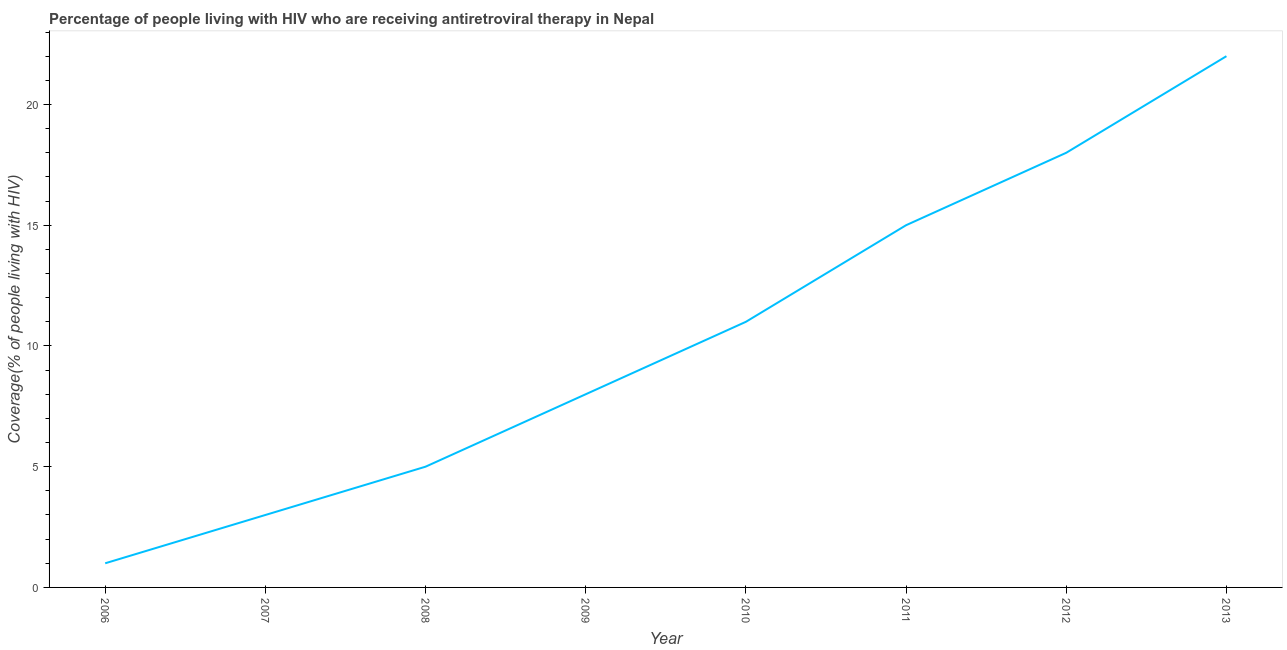What is the antiretroviral therapy coverage in 2012?
Keep it short and to the point. 18. Across all years, what is the maximum antiretroviral therapy coverage?
Provide a short and direct response. 22. Across all years, what is the minimum antiretroviral therapy coverage?
Your answer should be very brief. 1. In which year was the antiretroviral therapy coverage maximum?
Offer a terse response. 2013. In which year was the antiretroviral therapy coverage minimum?
Your response must be concise. 2006. What is the sum of the antiretroviral therapy coverage?
Ensure brevity in your answer.  83. What is the difference between the antiretroviral therapy coverage in 2007 and 2013?
Keep it short and to the point. -19. What is the average antiretroviral therapy coverage per year?
Ensure brevity in your answer.  10.38. Do a majority of the years between 2006 and 2007 (inclusive) have antiretroviral therapy coverage greater than 17 %?
Give a very brief answer. No. What is the ratio of the antiretroviral therapy coverage in 2009 to that in 2011?
Offer a terse response. 0.53. Is the antiretroviral therapy coverage in 2009 less than that in 2010?
Your answer should be very brief. Yes. What is the difference between the highest and the second highest antiretroviral therapy coverage?
Offer a terse response. 4. What is the difference between the highest and the lowest antiretroviral therapy coverage?
Provide a succinct answer. 21. Does the antiretroviral therapy coverage monotonically increase over the years?
Provide a succinct answer. Yes. How many lines are there?
Your response must be concise. 1. Are the values on the major ticks of Y-axis written in scientific E-notation?
Ensure brevity in your answer.  No. What is the title of the graph?
Provide a succinct answer. Percentage of people living with HIV who are receiving antiretroviral therapy in Nepal. What is the label or title of the X-axis?
Provide a short and direct response. Year. What is the label or title of the Y-axis?
Ensure brevity in your answer.  Coverage(% of people living with HIV). What is the Coverage(% of people living with HIV) in 2008?
Your response must be concise. 5. What is the Coverage(% of people living with HIV) in 2009?
Your response must be concise. 8. What is the Coverage(% of people living with HIV) of 2012?
Provide a succinct answer. 18. What is the difference between the Coverage(% of people living with HIV) in 2006 and 2007?
Your response must be concise. -2. What is the difference between the Coverage(% of people living with HIV) in 2006 and 2008?
Your response must be concise. -4. What is the difference between the Coverage(% of people living with HIV) in 2006 and 2010?
Offer a terse response. -10. What is the difference between the Coverage(% of people living with HIV) in 2006 and 2011?
Your answer should be compact. -14. What is the difference between the Coverage(% of people living with HIV) in 2006 and 2012?
Provide a short and direct response. -17. What is the difference between the Coverage(% of people living with HIV) in 2006 and 2013?
Ensure brevity in your answer.  -21. What is the difference between the Coverage(% of people living with HIV) in 2007 and 2009?
Your response must be concise. -5. What is the difference between the Coverage(% of people living with HIV) in 2007 and 2011?
Your response must be concise. -12. What is the difference between the Coverage(% of people living with HIV) in 2007 and 2013?
Offer a terse response. -19. What is the difference between the Coverage(% of people living with HIV) in 2008 and 2009?
Offer a terse response. -3. What is the difference between the Coverage(% of people living with HIV) in 2008 and 2010?
Keep it short and to the point. -6. What is the difference between the Coverage(% of people living with HIV) in 2008 and 2012?
Give a very brief answer. -13. What is the difference between the Coverage(% of people living with HIV) in 2008 and 2013?
Keep it short and to the point. -17. What is the difference between the Coverage(% of people living with HIV) in 2009 and 2010?
Give a very brief answer. -3. What is the difference between the Coverage(% of people living with HIV) in 2009 and 2013?
Your answer should be very brief. -14. What is the difference between the Coverage(% of people living with HIV) in 2010 and 2012?
Offer a very short reply. -7. What is the ratio of the Coverage(% of people living with HIV) in 2006 to that in 2007?
Make the answer very short. 0.33. What is the ratio of the Coverage(% of people living with HIV) in 2006 to that in 2010?
Give a very brief answer. 0.09. What is the ratio of the Coverage(% of people living with HIV) in 2006 to that in 2011?
Ensure brevity in your answer.  0.07. What is the ratio of the Coverage(% of people living with HIV) in 2006 to that in 2012?
Make the answer very short. 0.06. What is the ratio of the Coverage(% of people living with HIV) in 2006 to that in 2013?
Your answer should be compact. 0.04. What is the ratio of the Coverage(% of people living with HIV) in 2007 to that in 2009?
Your answer should be compact. 0.38. What is the ratio of the Coverage(% of people living with HIV) in 2007 to that in 2010?
Give a very brief answer. 0.27. What is the ratio of the Coverage(% of people living with HIV) in 2007 to that in 2012?
Provide a short and direct response. 0.17. What is the ratio of the Coverage(% of people living with HIV) in 2007 to that in 2013?
Provide a short and direct response. 0.14. What is the ratio of the Coverage(% of people living with HIV) in 2008 to that in 2009?
Keep it short and to the point. 0.62. What is the ratio of the Coverage(% of people living with HIV) in 2008 to that in 2010?
Your response must be concise. 0.46. What is the ratio of the Coverage(% of people living with HIV) in 2008 to that in 2011?
Your response must be concise. 0.33. What is the ratio of the Coverage(% of people living with HIV) in 2008 to that in 2012?
Ensure brevity in your answer.  0.28. What is the ratio of the Coverage(% of people living with HIV) in 2008 to that in 2013?
Your answer should be compact. 0.23. What is the ratio of the Coverage(% of people living with HIV) in 2009 to that in 2010?
Keep it short and to the point. 0.73. What is the ratio of the Coverage(% of people living with HIV) in 2009 to that in 2011?
Ensure brevity in your answer.  0.53. What is the ratio of the Coverage(% of people living with HIV) in 2009 to that in 2012?
Offer a very short reply. 0.44. What is the ratio of the Coverage(% of people living with HIV) in 2009 to that in 2013?
Offer a terse response. 0.36. What is the ratio of the Coverage(% of people living with HIV) in 2010 to that in 2011?
Give a very brief answer. 0.73. What is the ratio of the Coverage(% of people living with HIV) in 2010 to that in 2012?
Provide a succinct answer. 0.61. What is the ratio of the Coverage(% of people living with HIV) in 2010 to that in 2013?
Make the answer very short. 0.5. What is the ratio of the Coverage(% of people living with HIV) in 2011 to that in 2012?
Offer a very short reply. 0.83. What is the ratio of the Coverage(% of people living with HIV) in 2011 to that in 2013?
Offer a very short reply. 0.68. What is the ratio of the Coverage(% of people living with HIV) in 2012 to that in 2013?
Make the answer very short. 0.82. 